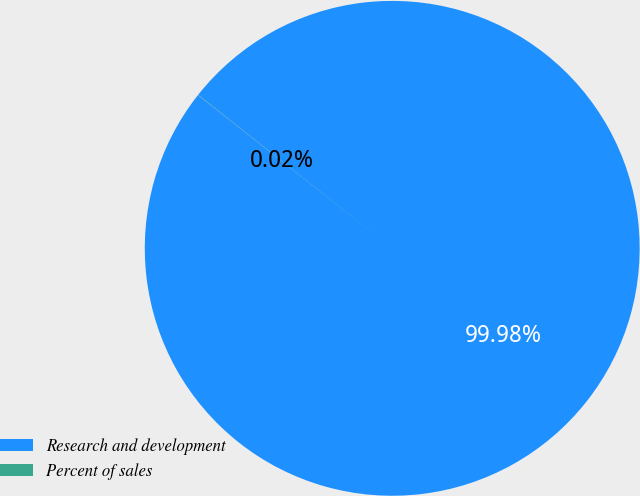Convert chart to OTSL. <chart><loc_0><loc_0><loc_500><loc_500><pie_chart><fcel>Research and development<fcel>Percent of sales<nl><fcel>99.98%<fcel>0.02%<nl></chart> 